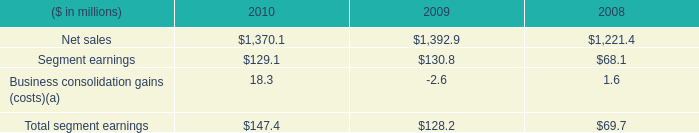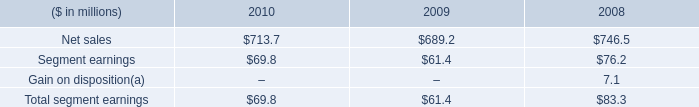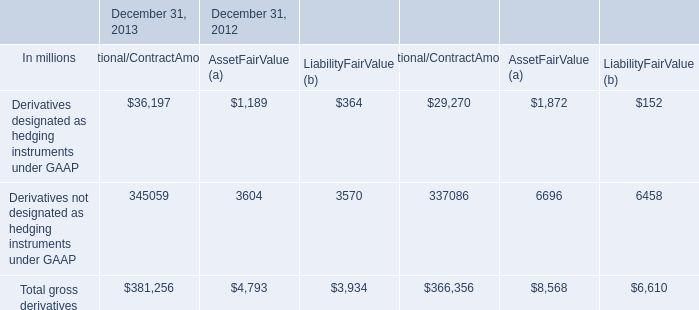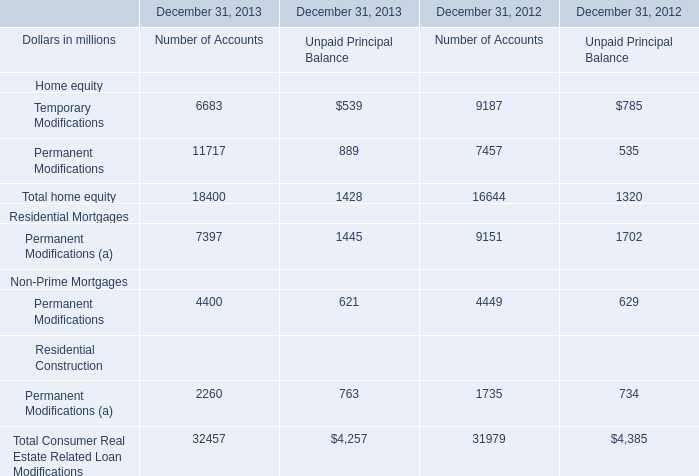What is the total amount of Net sales of 2008, Permanent Modifications of December 31, 2012 Number of Accounts, and Derivatives designated as hedging instruments under GAAP of December 31, 2013 Notional/ContractAmount ? 
Computations: ((1221.4 + 7457.0) + 36197.0)
Answer: 44875.4. 